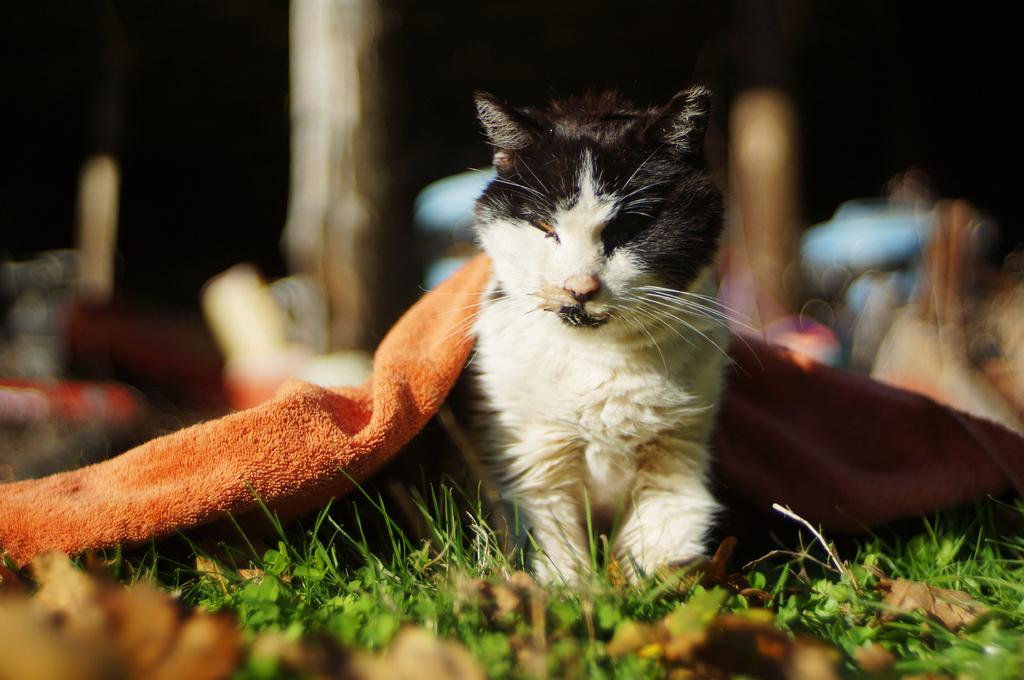What type of animal is in the image? There is a small kitten in the image. Where is the kitten located? The kitten is on the grass. What is above the kitten? There is an orange cloth above the kitten. How would you describe the background of the image? The background of the image is blurry. What is the chance of the kitten winning a brush in the image? There is no mention of a brush or any competition in the image, so it's not possible to determine the kitten's chances of winning one. 